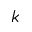Convert formula to latex. <formula><loc_0><loc_0><loc_500><loc_500>k</formula> 